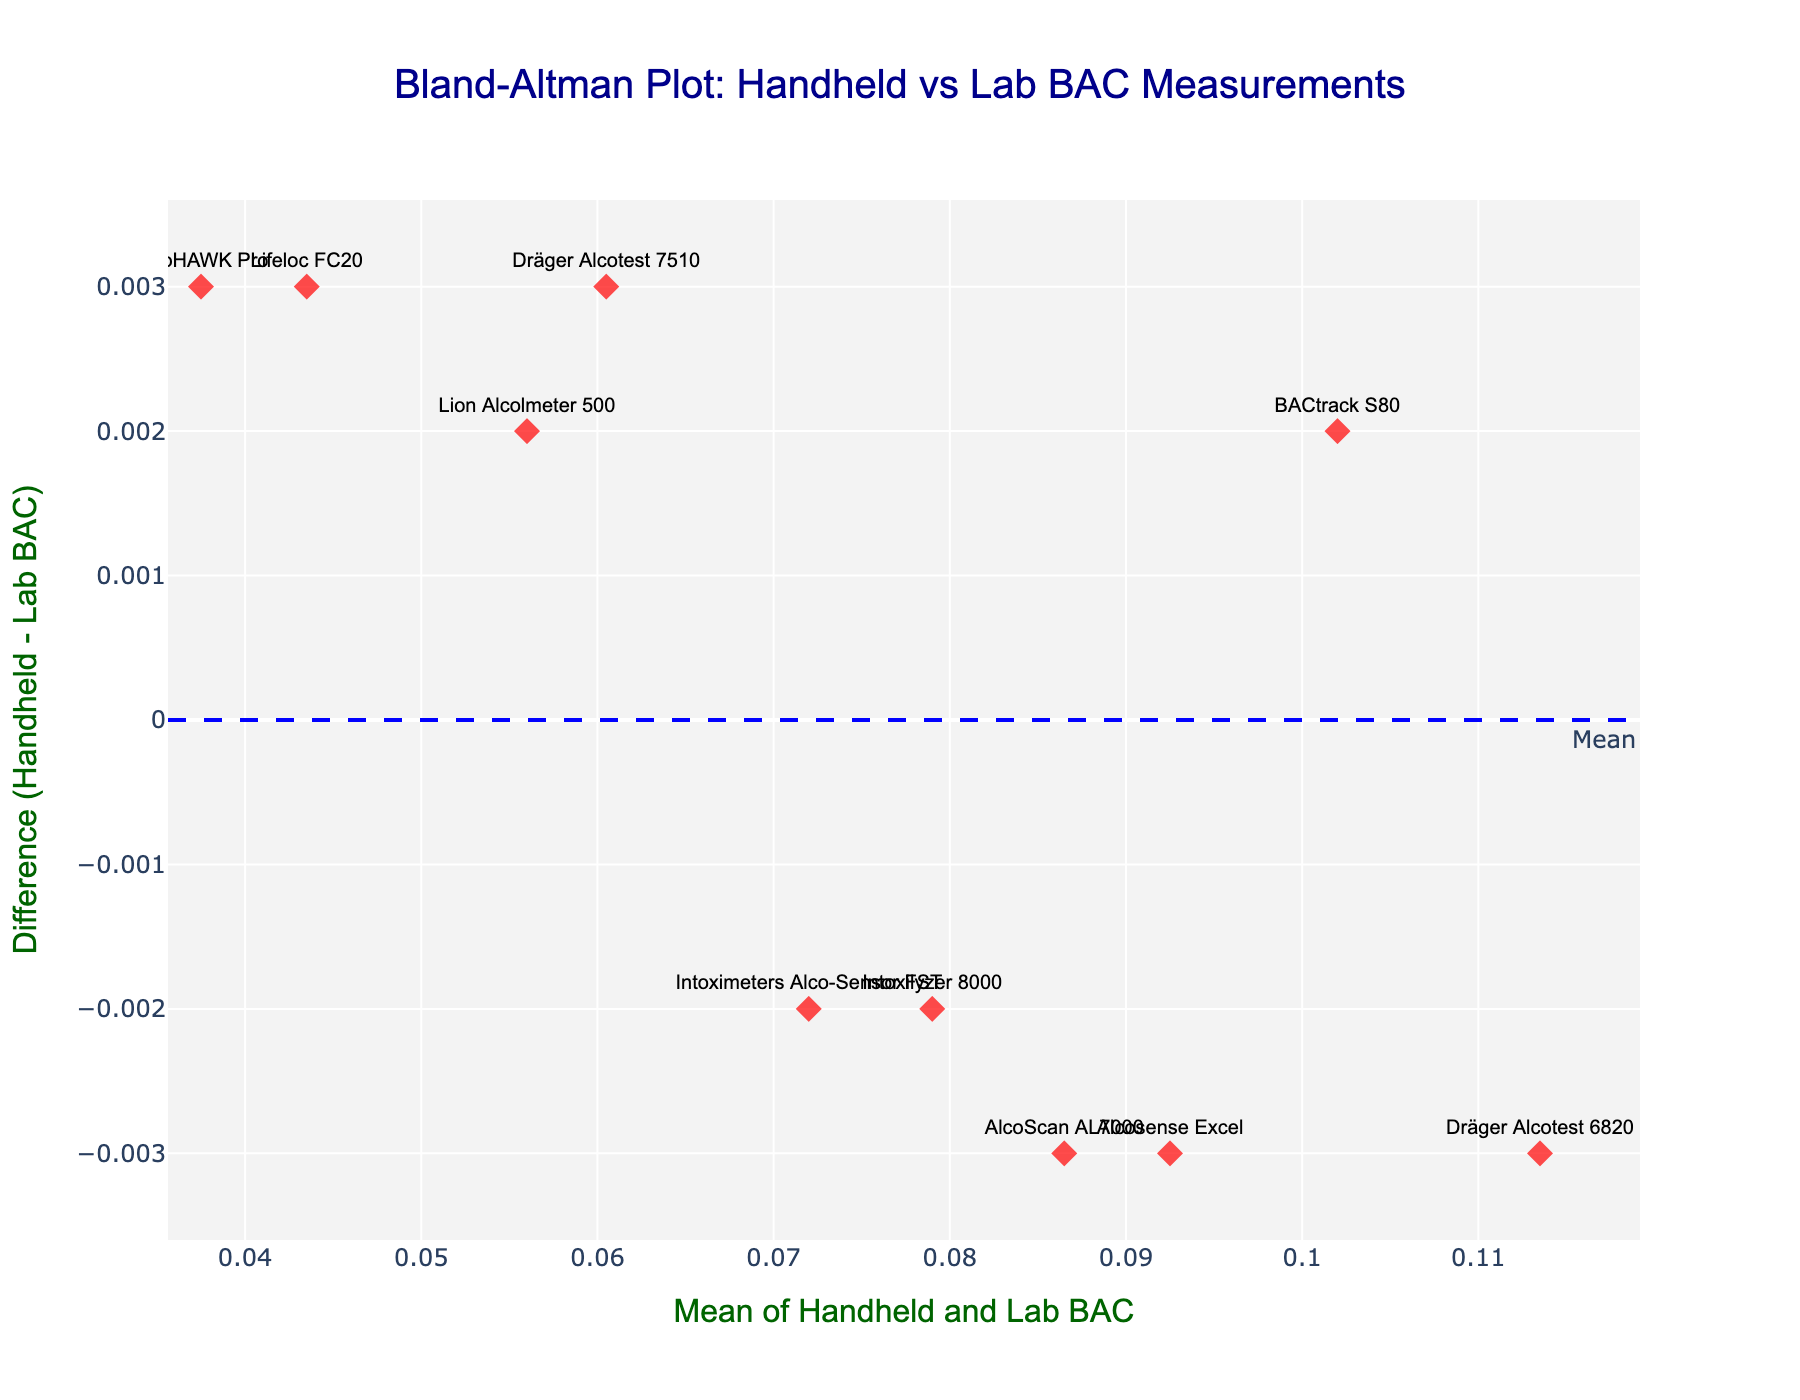What's the title of the figure? The title is typically displayed at the top of the plot.
Answer: Bland-Altman Plot: Handheld vs Lab BAC Measurements How many devices are represented in the plot? Each device is represented by a unique marker. Count them.
Answer: 10 What is the mean difference between Handheld and Lab BAC measurements? The mean difference is shown by the horizontal blue dashed line.
Answer: Close to 0 Which device has the highest BAC measurements in the plot? Locate the data point with the highest mean value on the x-axis.
Answer: Dräger Alcotest 6820 What color is used for the data points' markers in the plot? The color of the markers is visible in the plot.
Answer: Red Which device has the largest positive difference between Handheld and Lab BAC measurements? Look for the highest point on the y-axis (difference).
Answer: BACtrack S80 What are the lines representing limits of agreement in the plot, and what color are they? The limits of agreement are represented by the green dotted lines.
Answer: Green dotted lines What's the mean BAC value for the device "Alcosense Excel"? Find the data point for "Alcosense Excel" and calculate the mean of Handheld and Lab BAC values. Mean = (0.091 + 0.094)/2
Answer: 0.0925 What range is used for the x-axis in the plot? Based on the x-axis ticks, the lower and upper bounds are visible.
Answer: Approximately 0.04 to 0.115 Is there any device with a negative difference between Handheld and Lab BAC measurements? If yes, name one. Look for data points below the zero line on the y-axis.
Answer: Yes, AlcoScan AL7000 